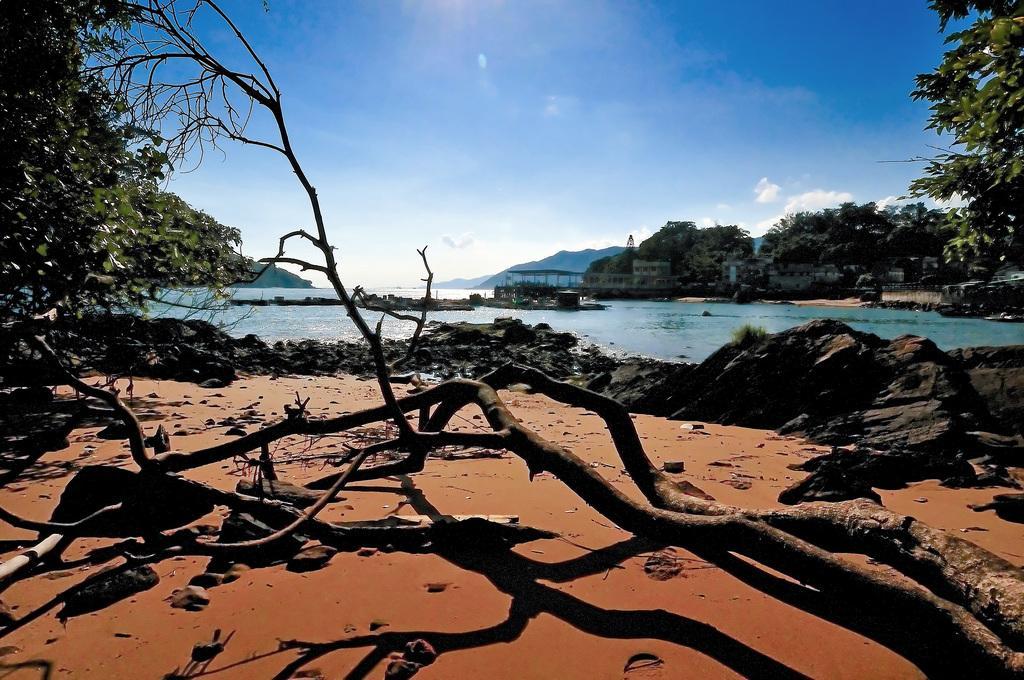Describe this image in one or two sentences. In this picture we can see there are branches, rocks and a river. Behind the river there are buildings, trees, hills and the sky. 